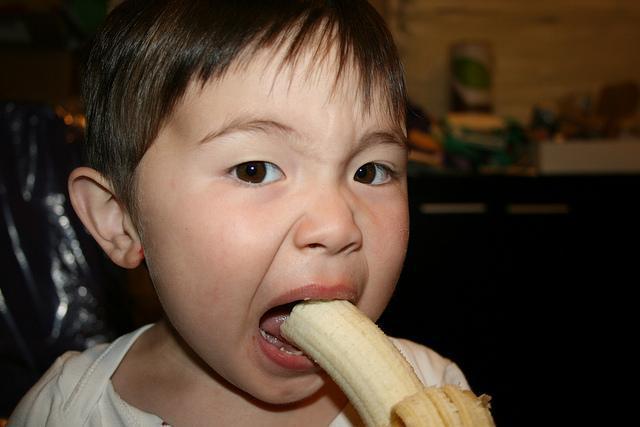How many bruises are on the banana?
Give a very brief answer. 0. 